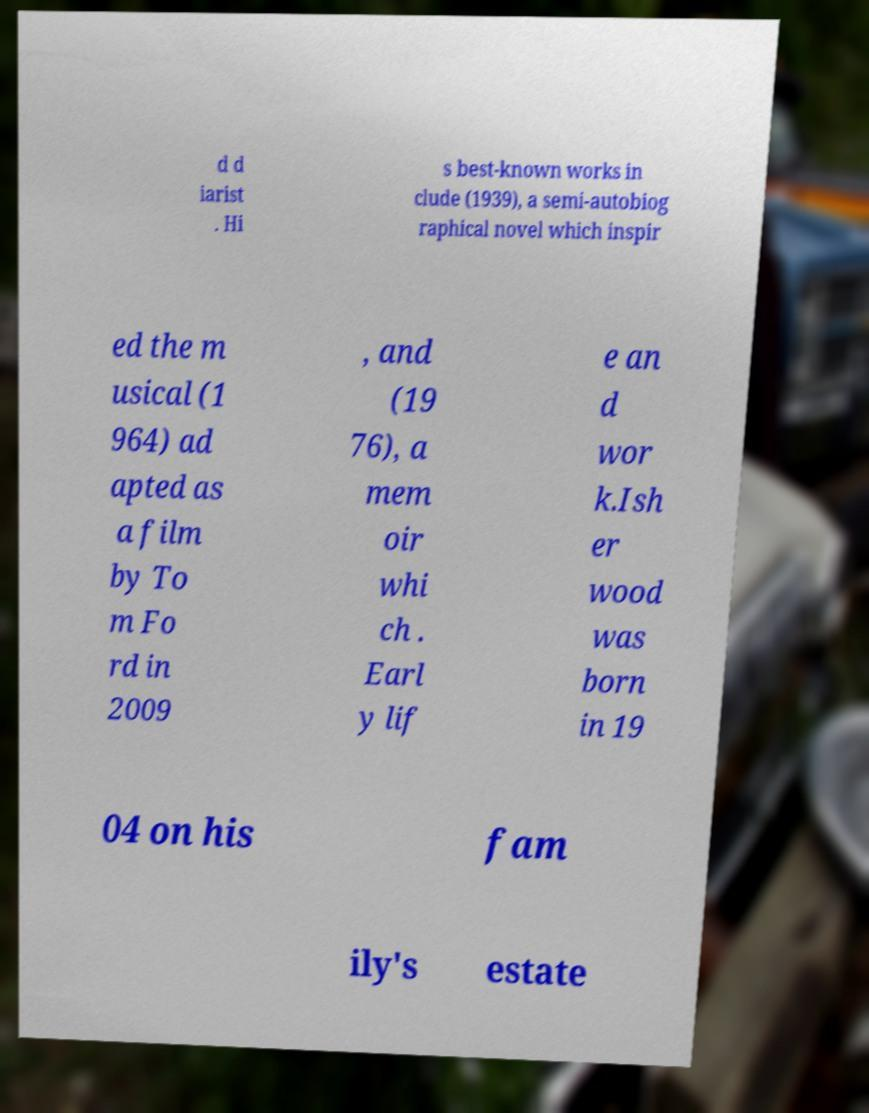I need the written content from this picture converted into text. Can you do that? d d iarist . Hi s best-known works in clude (1939), a semi-autobiog raphical novel which inspir ed the m usical (1 964) ad apted as a film by To m Fo rd in 2009 , and (19 76), a mem oir whi ch . Earl y lif e an d wor k.Ish er wood was born in 19 04 on his fam ily's estate 